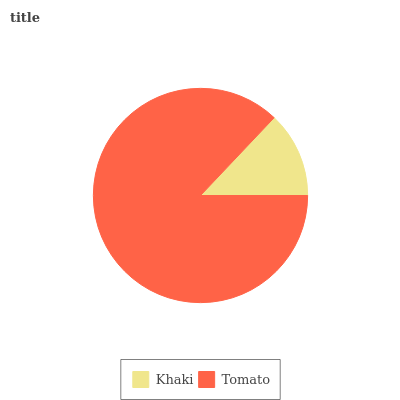Is Khaki the minimum?
Answer yes or no. Yes. Is Tomato the maximum?
Answer yes or no. Yes. Is Tomato the minimum?
Answer yes or no. No. Is Tomato greater than Khaki?
Answer yes or no. Yes. Is Khaki less than Tomato?
Answer yes or no. Yes. Is Khaki greater than Tomato?
Answer yes or no. No. Is Tomato less than Khaki?
Answer yes or no. No. Is Tomato the high median?
Answer yes or no. Yes. Is Khaki the low median?
Answer yes or no. Yes. Is Khaki the high median?
Answer yes or no. No. Is Tomato the low median?
Answer yes or no. No. 